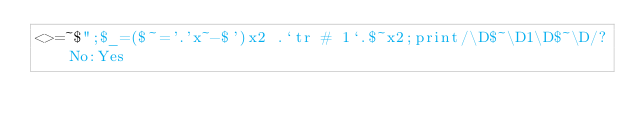<code> <loc_0><loc_0><loc_500><loc_500><_Perl_><>=~$";$_=($~='.'x~-$')x2 .`tr # 1`.$~x2;print/\D$~\D1\D$~\D/?No:Yes</code> 